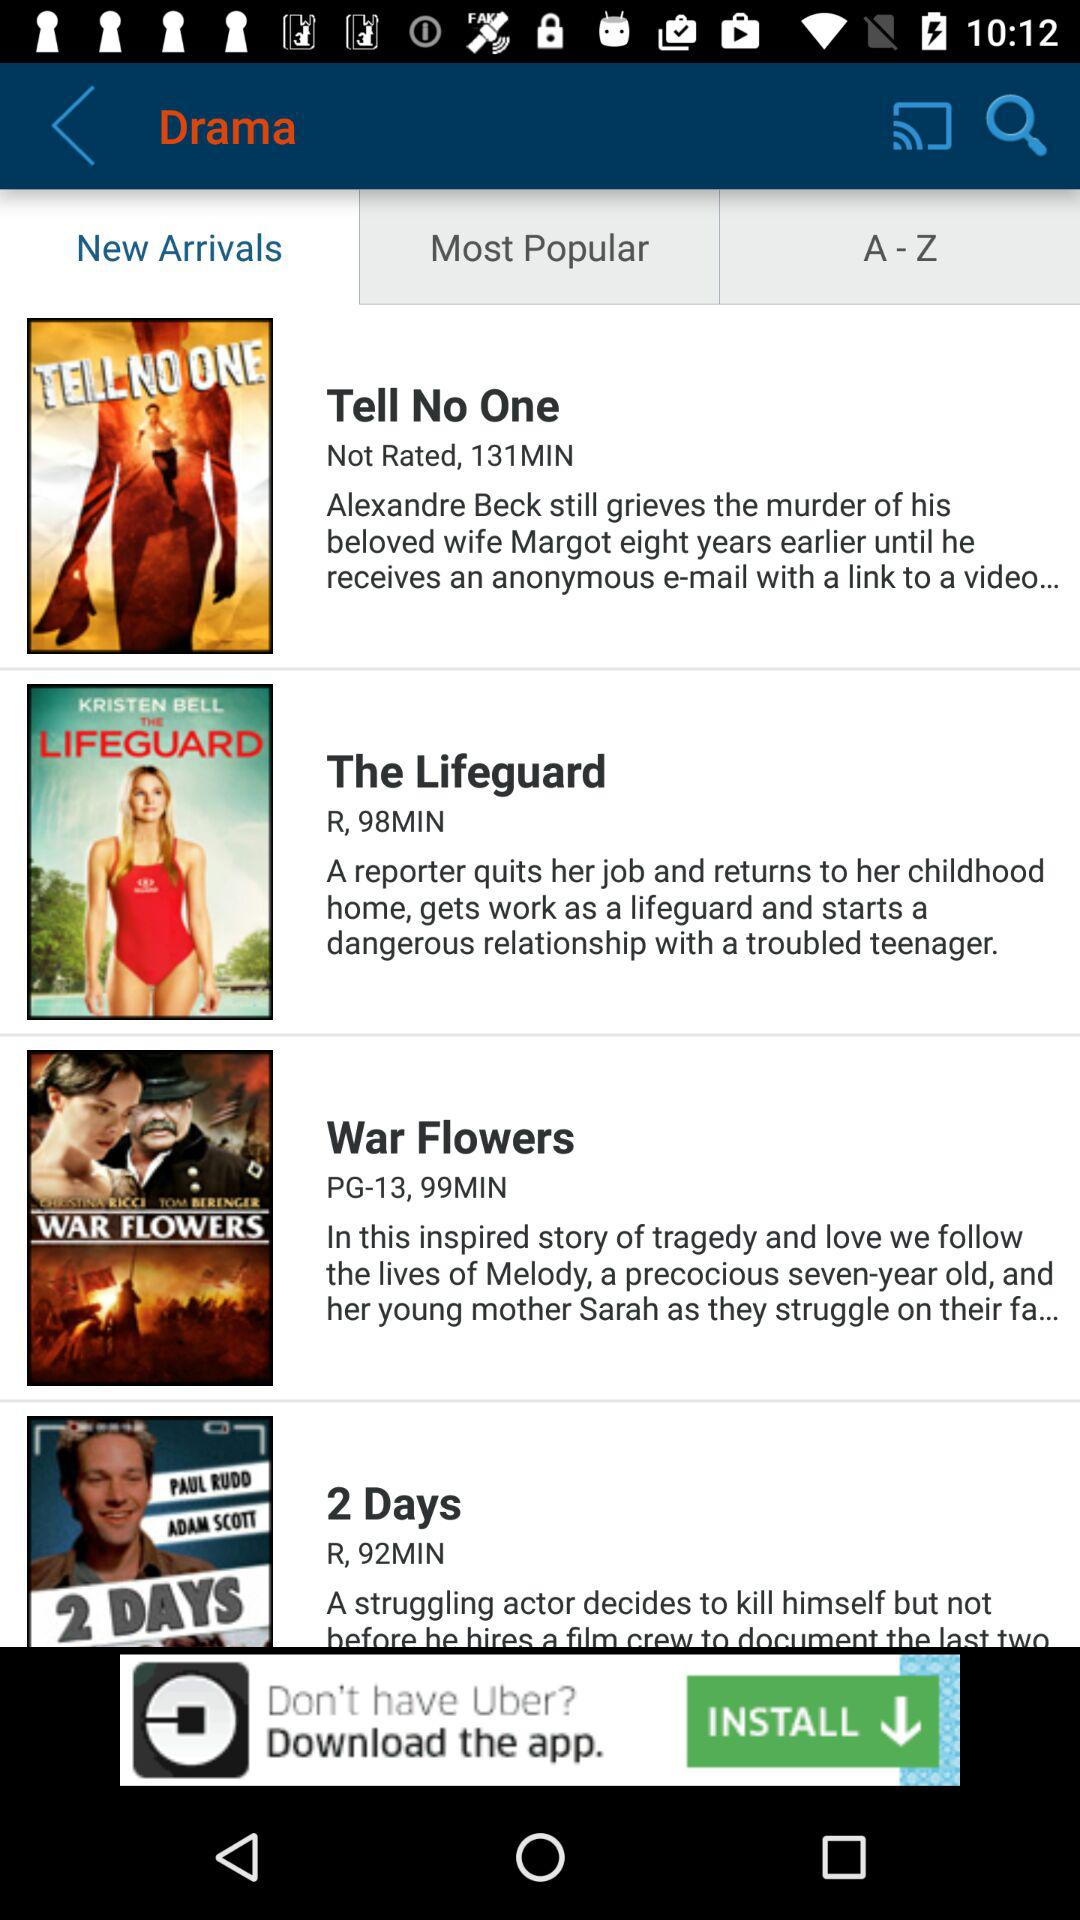What is the rating of the drama "2 Days"? The rating of the drama "2 Days" is R. 